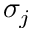<formula> <loc_0><loc_0><loc_500><loc_500>\sigma _ { j }</formula> 